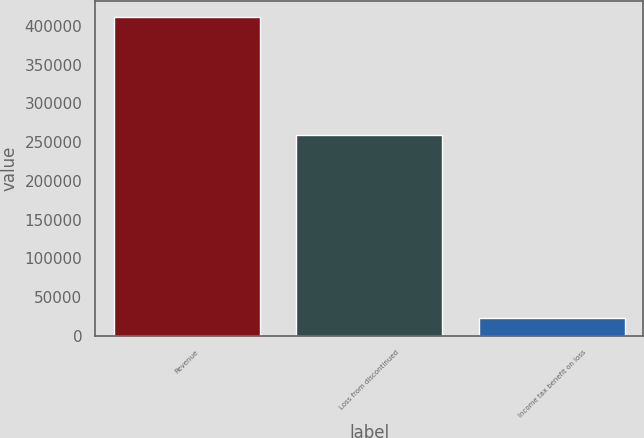Convert chart to OTSL. <chart><loc_0><loc_0><loc_500><loc_500><bar_chart><fcel>Revenue<fcel>Loss from discontinued<fcel>Income tax benefit on loss<nl><fcel>412053<fcel>258724<fcel>22965<nl></chart> 